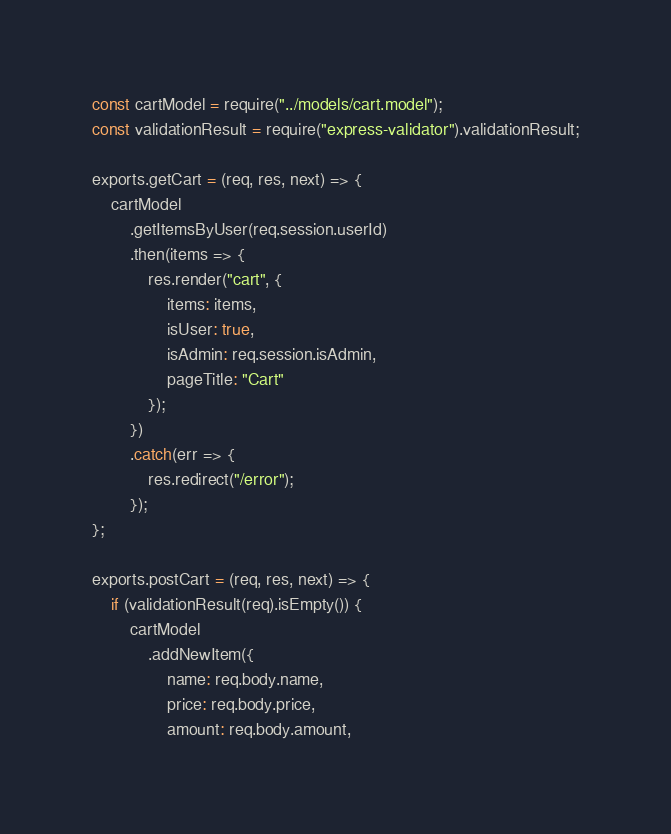<code> <loc_0><loc_0><loc_500><loc_500><_JavaScript_>const cartModel = require("../models/cart.model");
const validationResult = require("express-validator").validationResult;

exports.getCart = (req, res, next) => {
    cartModel
        .getItemsByUser(req.session.userId)
        .then(items => {
            res.render("cart", {
                items: items,
                isUser: true,
                isAdmin: req.session.isAdmin,
                pageTitle: "Cart"
            });
        })
        .catch(err => {
            res.redirect("/error");
        });
};

exports.postCart = (req, res, next) => {
    if (validationResult(req).isEmpty()) {
        cartModel
            .addNewItem({
                name: req.body.name,
                price: req.body.price,
                amount: req.body.amount,</code> 